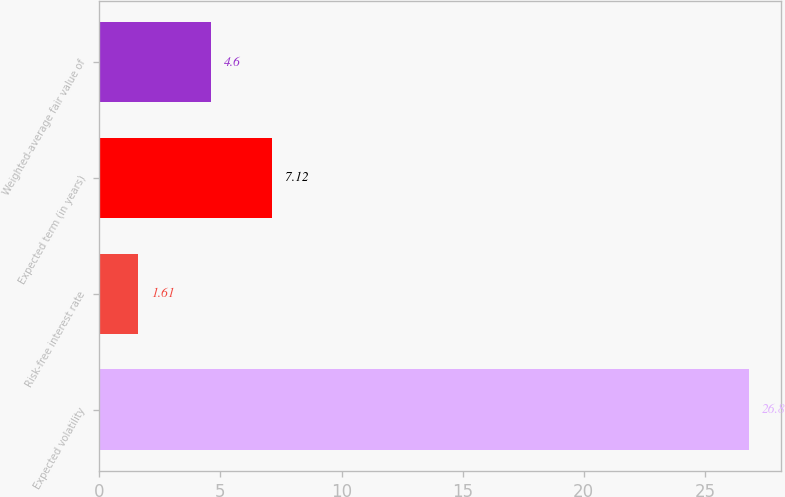<chart> <loc_0><loc_0><loc_500><loc_500><bar_chart><fcel>Expected volatility<fcel>Risk-free interest rate<fcel>Expected term (in years)<fcel>Weighted-average fair value of<nl><fcel>26.8<fcel>1.61<fcel>7.12<fcel>4.6<nl></chart> 